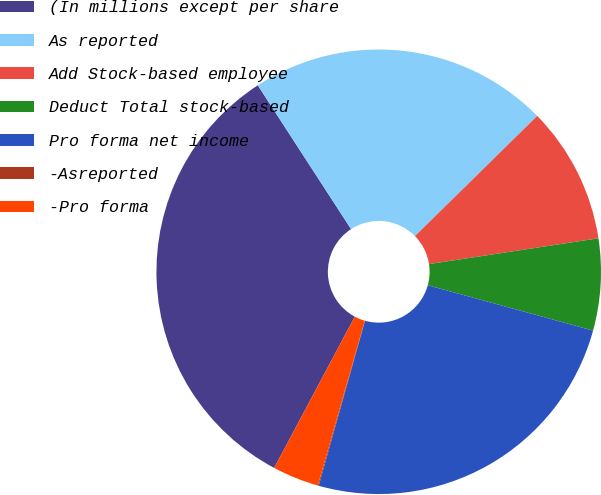Convert chart to OTSL. <chart><loc_0><loc_0><loc_500><loc_500><pie_chart><fcel>(In millions except per share<fcel>As reported<fcel>Add Stock-based employee<fcel>Deduct Total stock-based<fcel>Pro forma net income<fcel>-Asreported<fcel>-Pro forma<nl><fcel>33.05%<fcel>21.79%<fcel>9.96%<fcel>6.67%<fcel>25.09%<fcel>0.07%<fcel>3.37%<nl></chart> 